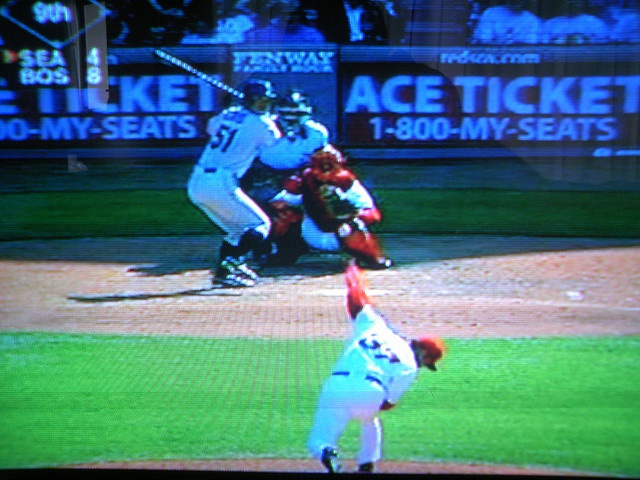Describe the objects in this image and their specific colors. I can see people in black, lightblue, and white tones, people in black, lightblue, and blue tones, people in black, maroon, brown, and white tones, people in black, lightblue, navy, and blue tones, and people in black, blue, gray, and navy tones in this image. 